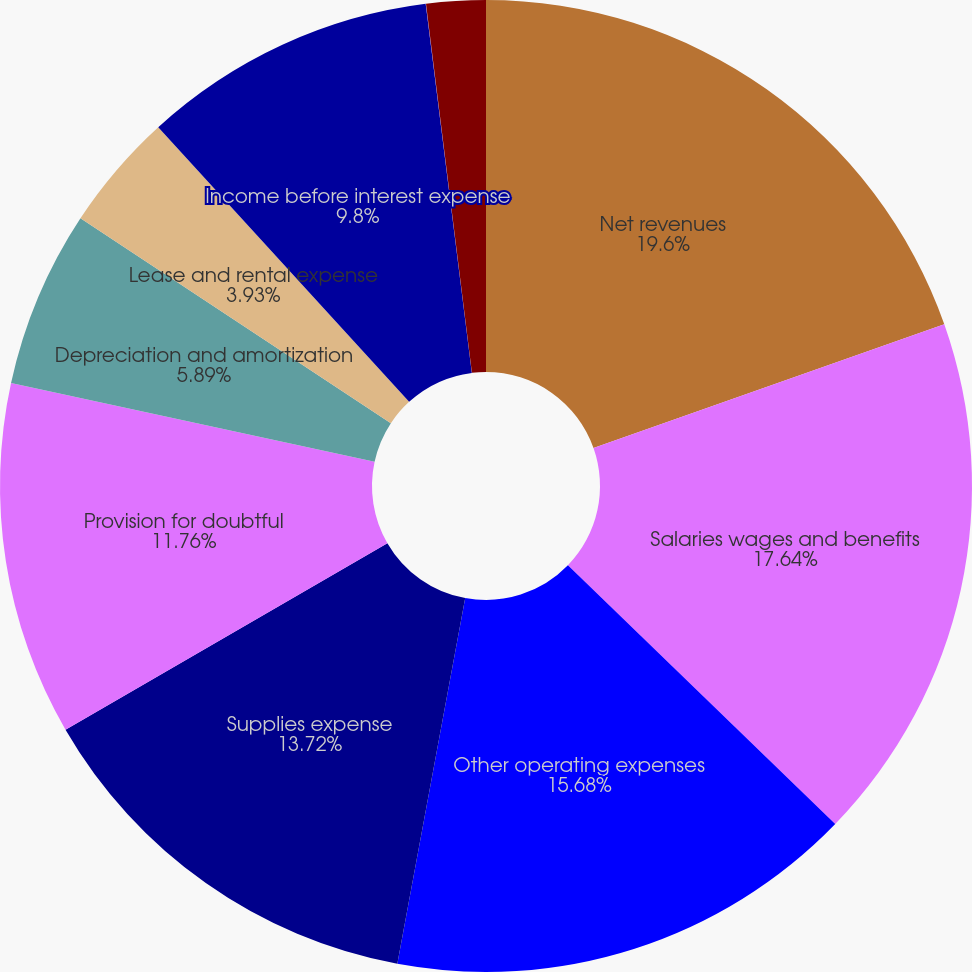Convert chart to OTSL. <chart><loc_0><loc_0><loc_500><loc_500><pie_chart><fcel>Net revenues<fcel>Salaries wages and benefits<fcel>Other operating expenses<fcel>Supplies expense<fcel>Provision for doubtful<fcel>Depreciation and amortization<fcel>Lease and rental expense<fcel>Income before interest expense<fcel>Interest expense net<fcel>Minority interests in earnings<nl><fcel>19.6%<fcel>17.64%<fcel>15.68%<fcel>13.72%<fcel>11.76%<fcel>5.89%<fcel>3.93%<fcel>9.8%<fcel>0.01%<fcel>1.97%<nl></chart> 